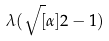<formula> <loc_0><loc_0><loc_500><loc_500>\lambda ( \sqrt { [ } \alpha ] { 2 } - 1 )</formula> 